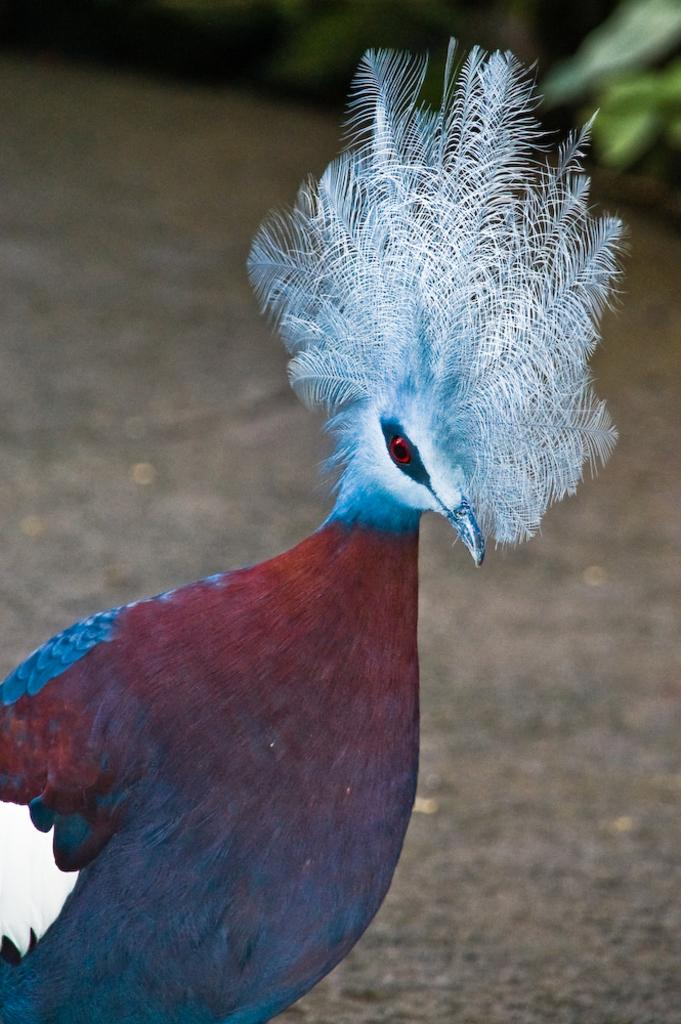What type of animal is in the image? There is a peacock in the image. Where is the peacock located in the image? The peacock is on the ground. Can you describe the background of the image? The background of the image is blurry. How many trees can be seen in the image? There are no trees visible in the image; it features a peacock on the ground with a blurry background. What type of wax is used to create the peacock's feathers in the image? The image is a photograph, not a drawing or painting, so there is no wax used to create the peacock's feathers. 